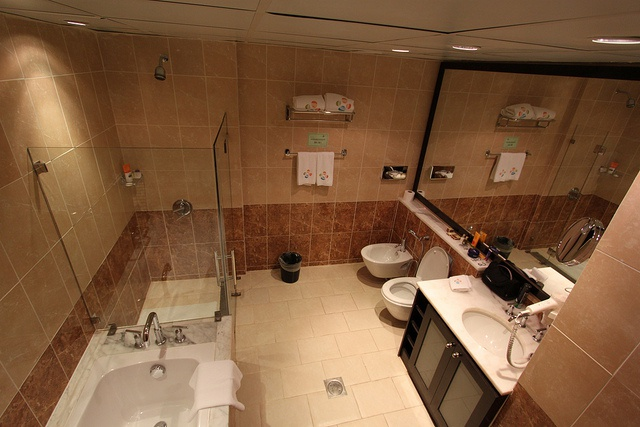Describe the objects in this image and their specific colors. I can see sink in gray and tan tones, sink in gray and tan tones, toilet in gray and tan tones, and hair drier in gray, tan, and beige tones in this image. 